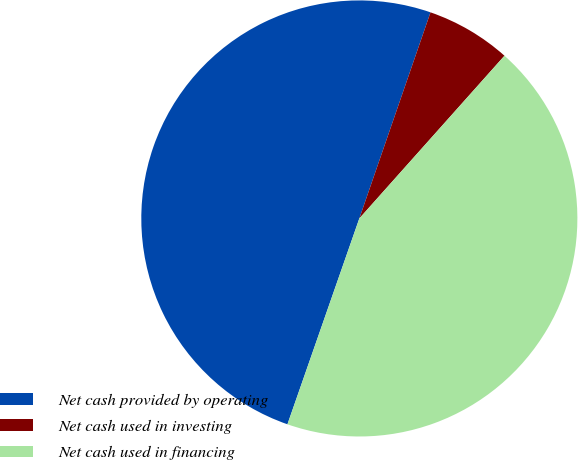<chart> <loc_0><loc_0><loc_500><loc_500><pie_chart><fcel>Net cash provided by operating<fcel>Net cash used in investing<fcel>Net cash used in financing<nl><fcel>49.94%<fcel>6.3%<fcel>43.75%<nl></chart> 